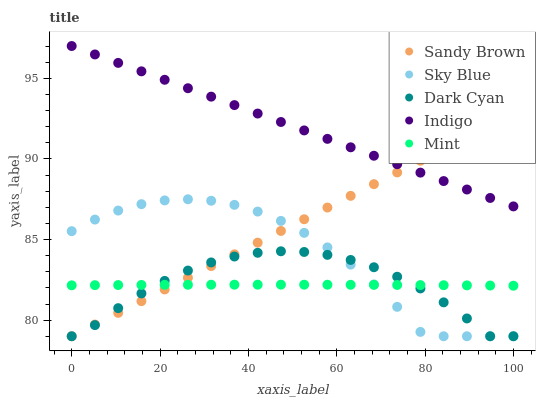Does Mint have the minimum area under the curve?
Answer yes or no. Yes. Does Indigo have the maximum area under the curve?
Answer yes or no. Yes. Does Sky Blue have the minimum area under the curve?
Answer yes or no. No. Does Sky Blue have the maximum area under the curve?
Answer yes or no. No. Is Indigo the smoothest?
Answer yes or no. Yes. Is Sky Blue the roughest?
Answer yes or no. Yes. Is Sandy Brown the smoothest?
Answer yes or no. No. Is Sandy Brown the roughest?
Answer yes or no. No. Does Dark Cyan have the lowest value?
Answer yes or no. Yes. Does Mint have the lowest value?
Answer yes or no. No. Does Indigo have the highest value?
Answer yes or no. Yes. Does Sky Blue have the highest value?
Answer yes or no. No. Is Dark Cyan less than Indigo?
Answer yes or no. Yes. Is Indigo greater than Dark Cyan?
Answer yes or no. Yes. Does Sandy Brown intersect Sky Blue?
Answer yes or no. Yes. Is Sandy Brown less than Sky Blue?
Answer yes or no. No. Is Sandy Brown greater than Sky Blue?
Answer yes or no. No. Does Dark Cyan intersect Indigo?
Answer yes or no. No. 